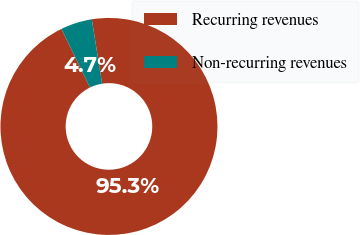Convert chart. <chart><loc_0><loc_0><loc_500><loc_500><pie_chart><fcel>Recurring revenues<fcel>Non-recurring revenues<nl><fcel>95.31%<fcel>4.69%<nl></chart> 